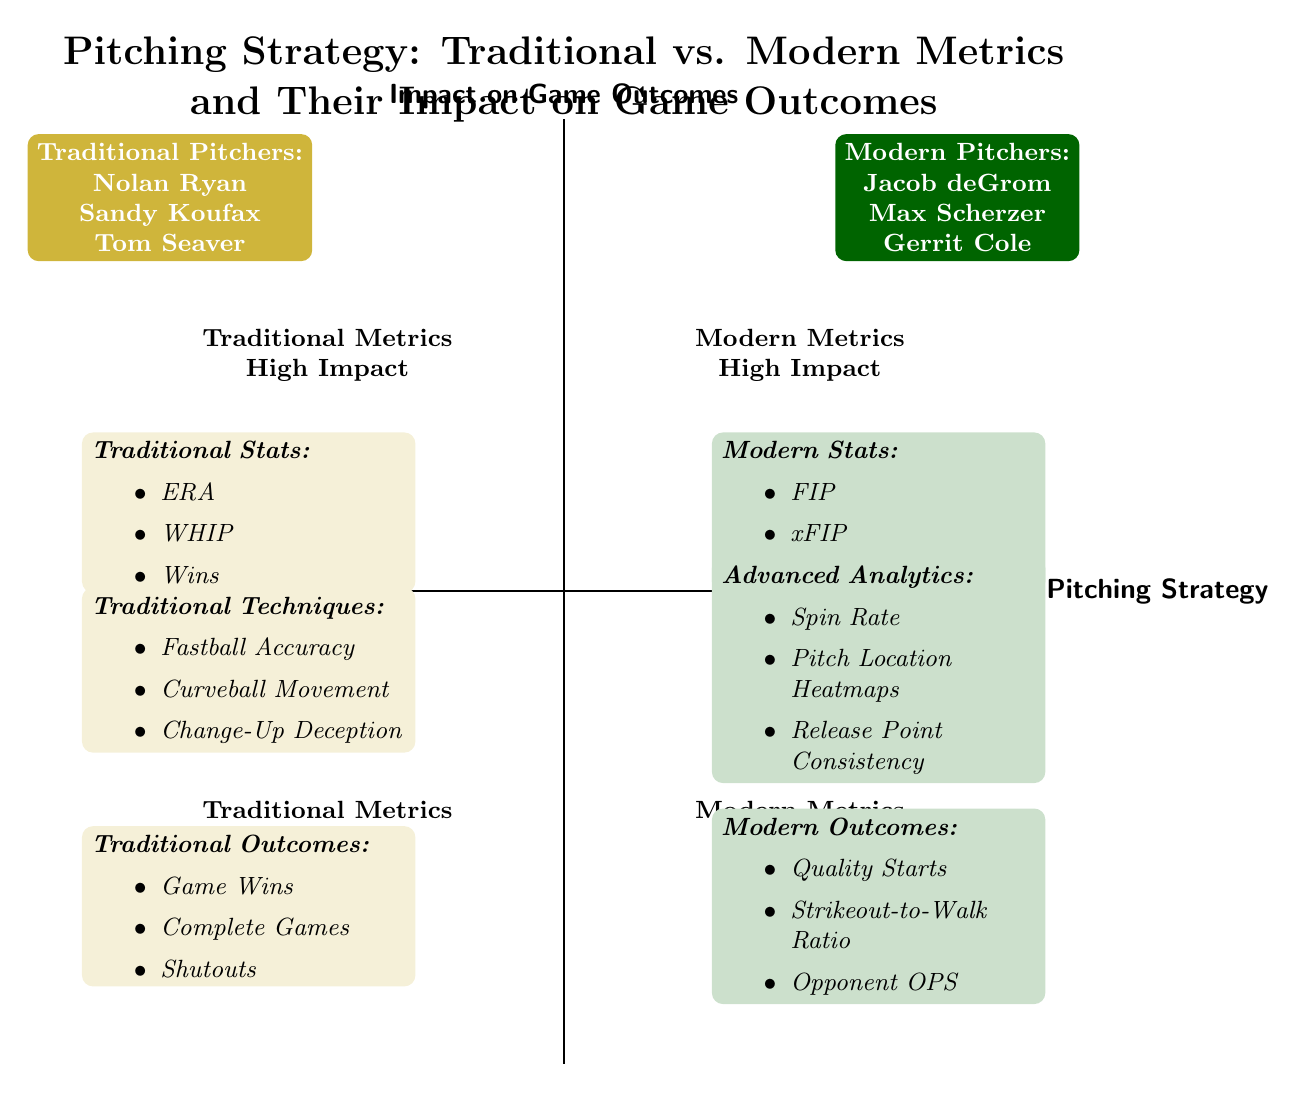What are the traditional pitching stats listed in the diagram? The traditional pitching stats are located in the upper left quadrant of the diagram, which includes ERA, WHIP, and Wins. I can see these items listed under the "Traditional Stats" section.
Answer: ERA, WHIP, Wins Which pitchers are categorized as modern according to the diagram? The modern pitchers are in the upper right quadrant of the diagram. The names provided there are Jacob deGrom, Max Scherzer, and Gerrit Cole.
Answer: Jacob deGrom, Max Scherzer, Gerrit Cole What is the relationship between traditional stats and game outcomes in terms of impact? Traditional stats, which are found in the upper left quadrant, correlate with high impact on game outcomes, indicated by their placement above the x-axis in the diagram. Therefore, they contribute significantly to game outcomes.
Answer: High Impact How many advanced analytics are listed in the modern metrics section? The modern metrics section contains advanced analytics listed in the lower right quadrant. There are three analytics mentioned: Spin Rate, Pitch Location Heatmaps, and Release Point Consistency. Thus, the total count is three.
Answer: 3 Which quadrant contains the pitching techniques? The pitching techniques are located in the lower left quadrant of the diagram, under the traditional metrics category. The label indicates it is part of "Traditional Metrics Low Impact".
Answer: Lower left quadrant What is the commonality between the "Complete Games" and "Opponent OPS"? Both "Complete Games" and "Opponent OPS" are listed as outcomes, but they appear in different quadrants—Complete Games in the lower left quadrant (traditional outcomes) and Opponent OPS in the lower right quadrant (modern outcomes). The commonality is that they both relate to game performance outcomes.
Answer: Game performance outcomes Which quadrant would you associate with modern metrics and high impact? The quadrant associated with modern metrics and high impact is the upper right quadrant of the diagram, which specifically contains modern stats like FIP, xFIP, and BABIP. The placement indicates a strong correlation in that context.
Answer: Upper right quadrant How many traditional outcomes are mentioned in the diagram? In the lower left quadrant, where the traditional outcomes are located, three outcomes are clearly listed: Game Wins, Complete Games, and Shutouts, making the total count three.
Answer: 3 What set of terms defines "modern stats" from the diagram? The modern stats are referenced in the upper right quadrant of the diagram. They specifically include FIP, xFIP, and BABIP, clearly identified under the "Modern Stats" label.
Answer: FIP, xFIP, BABIP 